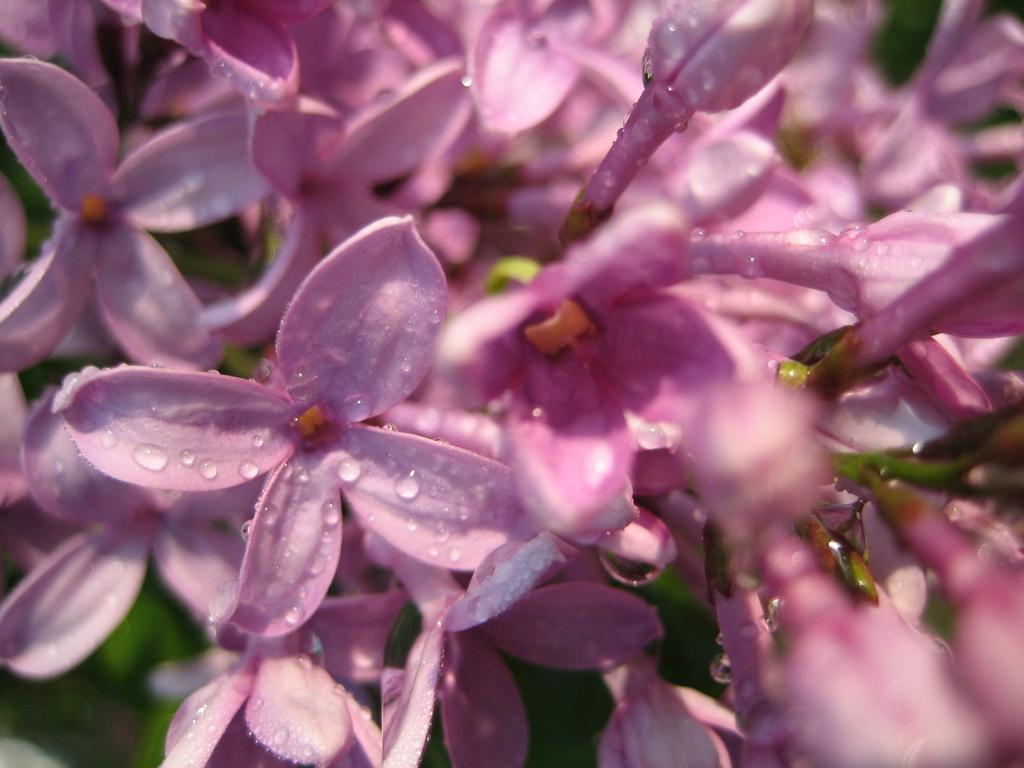What is the main subject of the image? The main subject of the image is a group of flowers. How are the flowers depicted in the image? The flowers are truncated in the image. Can you tell me how many girls are playing in the amusement park in the image? There is no girl or amusement park present in the image; it features a group of flowers. What type of land can be seen in the background of the image? There is no land visible in the image, as it only features a group of flowers. 